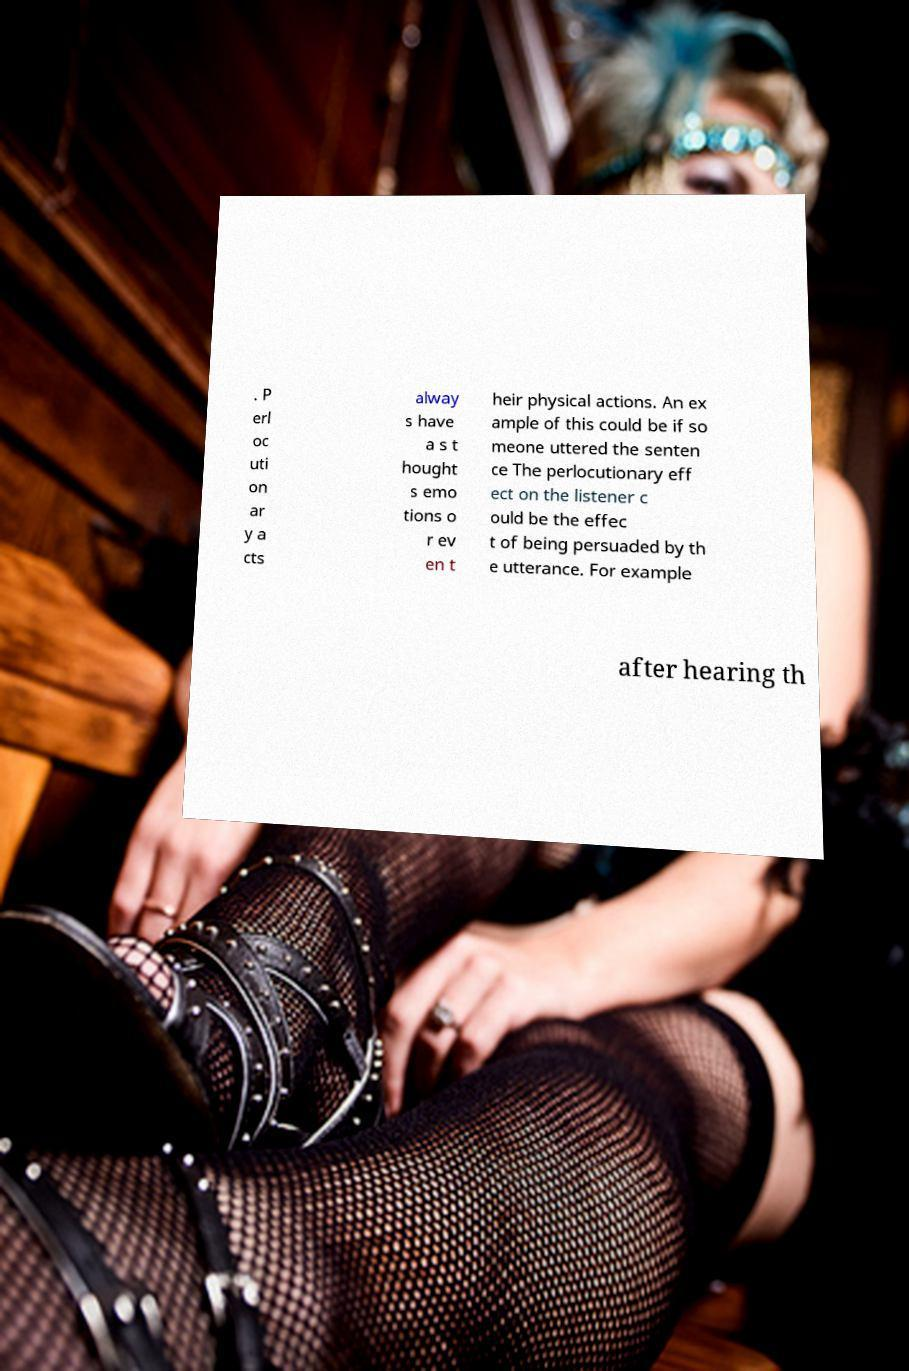Please identify and transcribe the text found in this image. . P erl oc uti on ar y a cts alway s have a s t hought s emo tions o r ev en t heir physical actions. An ex ample of this could be if so meone uttered the senten ce The perlocutionary eff ect on the listener c ould be the effec t of being persuaded by th e utterance. For example after hearing th 